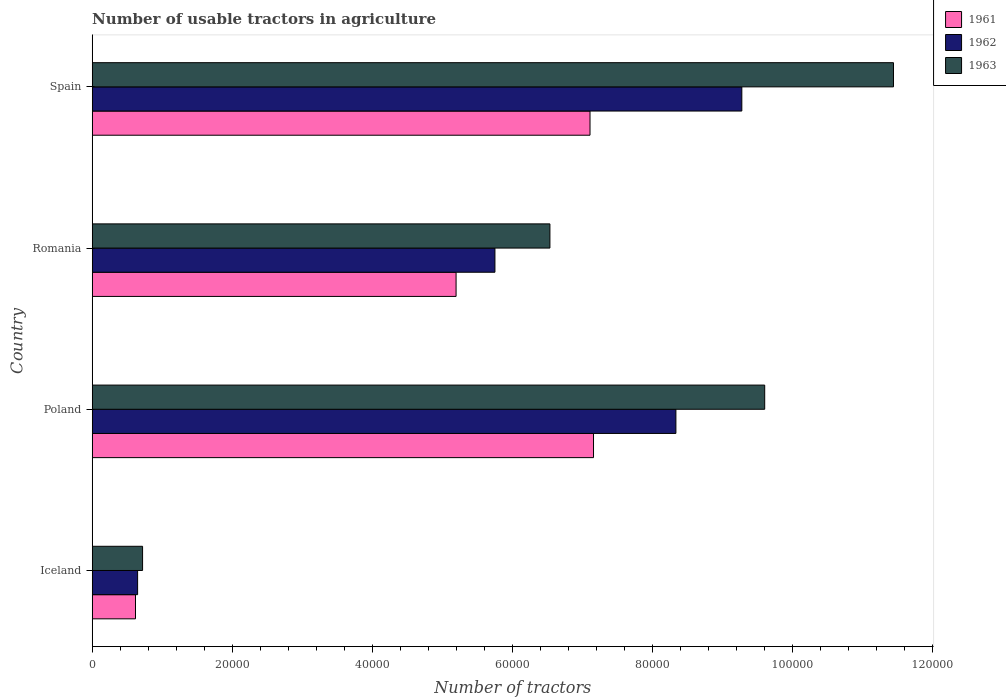Are the number of bars per tick equal to the number of legend labels?
Make the answer very short. Yes. Are the number of bars on each tick of the Y-axis equal?
Provide a short and direct response. Yes. How many bars are there on the 3rd tick from the top?
Provide a short and direct response. 3. What is the number of usable tractors in agriculture in 1963 in Iceland?
Your response must be concise. 7187. Across all countries, what is the maximum number of usable tractors in agriculture in 1961?
Offer a very short reply. 7.16e+04. Across all countries, what is the minimum number of usable tractors in agriculture in 1963?
Ensure brevity in your answer.  7187. In which country was the number of usable tractors in agriculture in 1961 maximum?
Your answer should be compact. Poland. What is the total number of usable tractors in agriculture in 1961 in the graph?
Keep it short and to the point. 2.01e+05. What is the difference between the number of usable tractors in agriculture in 1962 in Iceland and that in Spain?
Keep it short and to the point. -8.63e+04. What is the difference between the number of usable tractors in agriculture in 1962 in Poland and the number of usable tractors in agriculture in 1963 in Spain?
Your answer should be compact. -3.11e+04. What is the average number of usable tractors in agriculture in 1963 per country?
Offer a very short reply. 7.07e+04. What is the difference between the number of usable tractors in agriculture in 1963 and number of usable tractors in agriculture in 1962 in Spain?
Provide a succinct answer. 2.17e+04. In how many countries, is the number of usable tractors in agriculture in 1963 greater than 20000 ?
Offer a very short reply. 3. What is the ratio of the number of usable tractors in agriculture in 1961 in Iceland to that in Spain?
Your answer should be very brief. 0.09. What is the difference between the highest and the lowest number of usable tractors in agriculture in 1963?
Give a very brief answer. 1.07e+05. What does the 3rd bar from the bottom in Poland represents?
Provide a succinct answer. 1963. How many bars are there?
Your answer should be compact. 12. Are all the bars in the graph horizontal?
Your answer should be compact. Yes. How many countries are there in the graph?
Ensure brevity in your answer.  4. What is the difference between two consecutive major ticks on the X-axis?
Your answer should be very brief. 2.00e+04. Does the graph contain any zero values?
Offer a terse response. No. Where does the legend appear in the graph?
Keep it short and to the point. Top right. What is the title of the graph?
Ensure brevity in your answer.  Number of usable tractors in agriculture. Does "2000" appear as one of the legend labels in the graph?
Ensure brevity in your answer.  No. What is the label or title of the X-axis?
Offer a very short reply. Number of tractors. What is the label or title of the Y-axis?
Your answer should be compact. Country. What is the Number of tractors in 1961 in Iceland?
Provide a succinct answer. 6177. What is the Number of tractors of 1962 in Iceland?
Provide a short and direct response. 6479. What is the Number of tractors of 1963 in Iceland?
Keep it short and to the point. 7187. What is the Number of tractors of 1961 in Poland?
Your answer should be compact. 7.16e+04. What is the Number of tractors in 1962 in Poland?
Your response must be concise. 8.33e+04. What is the Number of tractors in 1963 in Poland?
Offer a terse response. 9.60e+04. What is the Number of tractors in 1961 in Romania?
Keep it short and to the point. 5.20e+04. What is the Number of tractors of 1962 in Romania?
Your answer should be compact. 5.75e+04. What is the Number of tractors of 1963 in Romania?
Provide a short and direct response. 6.54e+04. What is the Number of tractors of 1961 in Spain?
Offer a very short reply. 7.11e+04. What is the Number of tractors of 1962 in Spain?
Provide a succinct answer. 9.28e+04. What is the Number of tractors in 1963 in Spain?
Make the answer very short. 1.14e+05. Across all countries, what is the maximum Number of tractors in 1961?
Provide a succinct answer. 7.16e+04. Across all countries, what is the maximum Number of tractors of 1962?
Give a very brief answer. 9.28e+04. Across all countries, what is the maximum Number of tractors of 1963?
Provide a short and direct response. 1.14e+05. Across all countries, what is the minimum Number of tractors of 1961?
Ensure brevity in your answer.  6177. Across all countries, what is the minimum Number of tractors in 1962?
Provide a succinct answer. 6479. Across all countries, what is the minimum Number of tractors of 1963?
Provide a succinct answer. 7187. What is the total Number of tractors in 1961 in the graph?
Give a very brief answer. 2.01e+05. What is the total Number of tractors of 1962 in the graph?
Provide a succinct answer. 2.40e+05. What is the total Number of tractors in 1963 in the graph?
Provide a succinct answer. 2.83e+05. What is the difference between the Number of tractors in 1961 in Iceland and that in Poland?
Provide a short and direct response. -6.54e+04. What is the difference between the Number of tractors of 1962 in Iceland and that in Poland?
Provide a short and direct response. -7.69e+04. What is the difference between the Number of tractors in 1963 in Iceland and that in Poland?
Make the answer very short. -8.88e+04. What is the difference between the Number of tractors in 1961 in Iceland and that in Romania?
Provide a short and direct response. -4.58e+04. What is the difference between the Number of tractors in 1962 in Iceland and that in Romania?
Offer a terse response. -5.10e+04. What is the difference between the Number of tractors of 1963 in Iceland and that in Romania?
Make the answer very short. -5.82e+04. What is the difference between the Number of tractors in 1961 in Iceland and that in Spain?
Offer a terse response. -6.49e+04. What is the difference between the Number of tractors in 1962 in Iceland and that in Spain?
Keep it short and to the point. -8.63e+04. What is the difference between the Number of tractors of 1963 in Iceland and that in Spain?
Offer a very short reply. -1.07e+05. What is the difference between the Number of tractors in 1961 in Poland and that in Romania?
Your answer should be very brief. 1.96e+04. What is the difference between the Number of tractors in 1962 in Poland and that in Romania?
Keep it short and to the point. 2.58e+04. What is the difference between the Number of tractors of 1963 in Poland and that in Romania?
Provide a succinct answer. 3.07e+04. What is the difference between the Number of tractors of 1961 in Poland and that in Spain?
Provide a short and direct response. 500. What is the difference between the Number of tractors of 1962 in Poland and that in Spain?
Make the answer very short. -9414. What is the difference between the Number of tractors in 1963 in Poland and that in Spain?
Provide a succinct answer. -1.84e+04. What is the difference between the Number of tractors of 1961 in Romania and that in Spain?
Ensure brevity in your answer.  -1.91e+04. What is the difference between the Number of tractors of 1962 in Romania and that in Spain?
Offer a terse response. -3.53e+04. What is the difference between the Number of tractors in 1963 in Romania and that in Spain?
Your response must be concise. -4.91e+04. What is the difference between the Number of tractors in 1961 in Iceland and the Number of tractors in 1962 in Poland?
Your answer should be very brief. -7.72e+04. What is the difference between the Number of tractors in 1961 in Iceland and the Number of tractors in 1963 in Poland?
Provide a short and direct response. -8.98e+04. What is the difference between the Number of tractors in 1962 in Iceland and the Number of tractors in 1963 in Poland?
Your answer should be compact. -8.95e+04. What is the difference between the Number of tractors of 1961 in Iceland and the Number of tractors of 1962 in Romania?
Give a very brief answer. -5.13e+04. What is the difference between the Number of tractors of 1961 in Iceland and the Number of tractors of 1963 in Romania?
Offer a very short reply. -5.92e+04. What is the difference between the Number of tractors of 1962 in Iceland and the Number of tractors of 1963 in Romania?
Offer a terse response. -5.89e+04. What is the difference between the Number of tractors in 1961 in Iceland and the Number of tractors in 1962 in Spain?
Provide a short and direct response. -8.66e+04. What is the difference between the Number of tractors in 1961 in Iceland and the Number of tractors in 1963 in Spain?
Give a very brief answer. -1.08e+05. What is the difference between the Number of tractors of 1962 in Iceland and the Number of tractors of 1963 in Spain?
Offer a very short reply. -1.08e+05. What is the difference between the Number of tractors of 1961 in Poland and the Number of tractors of 1962 in Romania?
Offer a terse response. 1.41e+04. What is the difference between the Number of tractors of 1961 in Poland and the Number of tractors of 1963 in Romania?
Ensure brevity in your answer.  6226. What is the difference between the Number of tractors in 1962 in Poland and the Number of tractors in 1963 in Romania?
Your answer should be very brief. 1.80e+04. What is the difference between the Number of tractors of 1961 in Poland and the Number of tractors of 1962 in Spain?
Your answer should be compact. -2.12e+04. What is the difference between the Number of tractors of 1961 in Poland and the Number of tractors of 1963 in Spain?
Ensure brevity in your answer.  -4.28e+04. What is the difference between the Number of tractors of 1962 in Poland and the Number of tractors of 1963 in Spain?
Your answer should be very brief. -3.11e+04. What is the difference between the Number of tractors in 1961 in Romania and the Number of tractors in 1962 in Spain?
Give a very brief answer. -4.08e+04. What is the difference between the Number of tractors of 1961 in Romania and the Number of tractors of 1963 in Spain?
Your response must be concise. -6.25e+04. What is the difference between the Number of tractors in 1962 in Romania and the Number of tractors in 1963 in Spain?
Your response must be concise. -5.69e+04. What is the average Number of tractors in 1961 per country?
Your response must be concise. 5.02e+04. What is the average Number of tractors in 1962 per country?
Keep it short and to the point. 6.00e+04. What is the average Number of tractors of 1963 per country?
Offer a very short reply. 7.07e+04. What is the difference between the Number of tractors in 1961 and Number of tractors in 1962 in Iceland?
Your answer should be very brief. -302. What is the difference between the Number of tractors in 1961 and Number of tractors in 1963 in Iceland?
Your answer should be compact. -1010. What is the difference between the Number of tractors in 1962 and Number of tractors in 1963 in Iceland?
Provide a succinct answer. -708. What is the difference between the Number of tractors in 1961 and Number of tractors in 1962 in Poland?
Keep it short and to the point. -1.18e+04. What is the difference between the Number of tractors in 1961 and Number of tractors in 1963 in Poland?
Give a very brief answer. -2.44e+04. What is the difference between the Number of tractors of 1962 and Number of tractors of 1963 in Poland?
Your answer should be very brief. -1.27e+04. What is the difference between the Number of tractors in 1961 and Number of tractors in 1962 in Romania?
Offer a terse response. -5548. What is the difference between the Number of tractors of 1961 and Number of tractors of 1963 in Romania?
Your answer should be compact. -1.34e+04. What is the difference between the Number of tractors of 1962 and Number of tractors of 1963 in Romania?
Provide a succinct answer. -7851. What is the difference between the Number of tractors in 1961 and Number of tractors in 1962 in Spain?
Your answer should be compact. -2.17e+04. What is the difference between the Number of tractors of 1961 and Number of tractors of 1963 in Spain?
Give a very brief answer. -4.33e+04. What is the difference between the Number of tractors in 1962 and Number of tractors in 1963 in Spain?
Your answer should be compact. -2.17e+04. What is the ratio of the Number of tractors in 1961 in Iceland to that in Poland?
Your answer should be compact. 0.09. What is the ratio of the Number of tractors in 1962 in Iceland to that in Poland?
Provide a succinct answer. 0.08. What is the ratio of the Number of tractors of 1963 in Iceland to that in Poland?
Ensure brevity in your answer.  0.07. What is the ratio of the Number of tractors in 1961 in Iceland to that in Romania?
Keep it short and to the point. 0.12. What is the ratio of the Number of tractors in 1962 in Iceland to that in Romania?
Offer a terse response. 0.11. What is the ratio of the Number of tractors of 1963 in Iceland to that in Romania?
Keep it short and to the point. 0.11. What is the ratio of the Number of tractors of 1961 in Iceland to that in Spain?
Make the answer very short. 0.09. What is the ratio of the Number of tractors in 1962 in Iceland to that in Spain?
Your answer should be compact. 0.07. What is the ratio of the Number of tractors of 1963 in Iceland to that in Spain?
Keep it short and to the point. 0.06. What is the ratio of the Number of tractors in 1961 in Poland to that in Romania?
Make the answer very short. 1.38. What is the ratio of the Number of tractors of 1962 in Poland to that in Romania?
Offer a very short reply. 1.45. What is the ratio of the Number of tractors of 1963 in Poland to that in Romania?
Make the answer very short. 1.47. What is the ratio of the Number of tractors of 1962 in Poland to that in Spain?
Your answer should be compact. 0.9. What is the ratio of the Number of tractors of 1963 in Poland to that in Spain?
Make the answer very short. 0.84. What is the ratio of the Number of tractors of 1961 in Romania to that in Spain?
Your response must be concise. 0.73. What is the ratio of the Number of tractors in 1962 in Romania to that in Spain?
Ensure brevity in your answer.  0.62. What is the ratio of the Number of tractors of 1963 in Romania to that in Spain?
Make the answer very short. 0.57. What is the difference between the highest and the second highest Number of tractors of 1961?
Your answer should be very brief. 500. What is the difference between the highest and the second highest Number of tractors of 1962?
Make the answer very short. 9414. What is the difference between the highest and the second highest Number of tractors of 1963?
Give a very brief answer. 1.84e+04. What is the difference between the highest and the lowest Number of tractors in 1961?
Provide a succinct answer. 6.54e+04. What is the difference between the highest and the lowest Number of tractors of 1962?
Make the answer very short. 8.63e+04. What is the difference between the highest and the lowest Number of tractors of 1963?
Your answer should be very brief. 1.07e+05. 